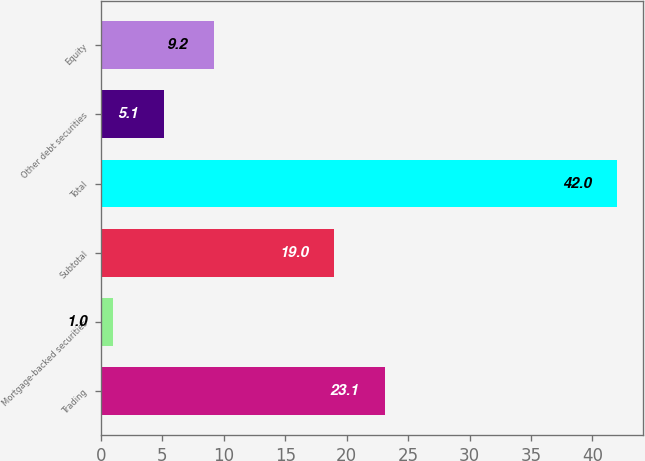Convert chart to OTSL. <chart><loc_0><loc_0><loc_500><loc_500><bar_chart><fcel>Trading<fcel>Mortgage-backed securities<fcel>Subtotal<fcel>Total<fcel>Other debt securities<fcel>Equity<nl><fcel>23.1<fcel>1<fcel>19<fcel>42<fcel>5.1<fcel>9.2<nl></chart> 